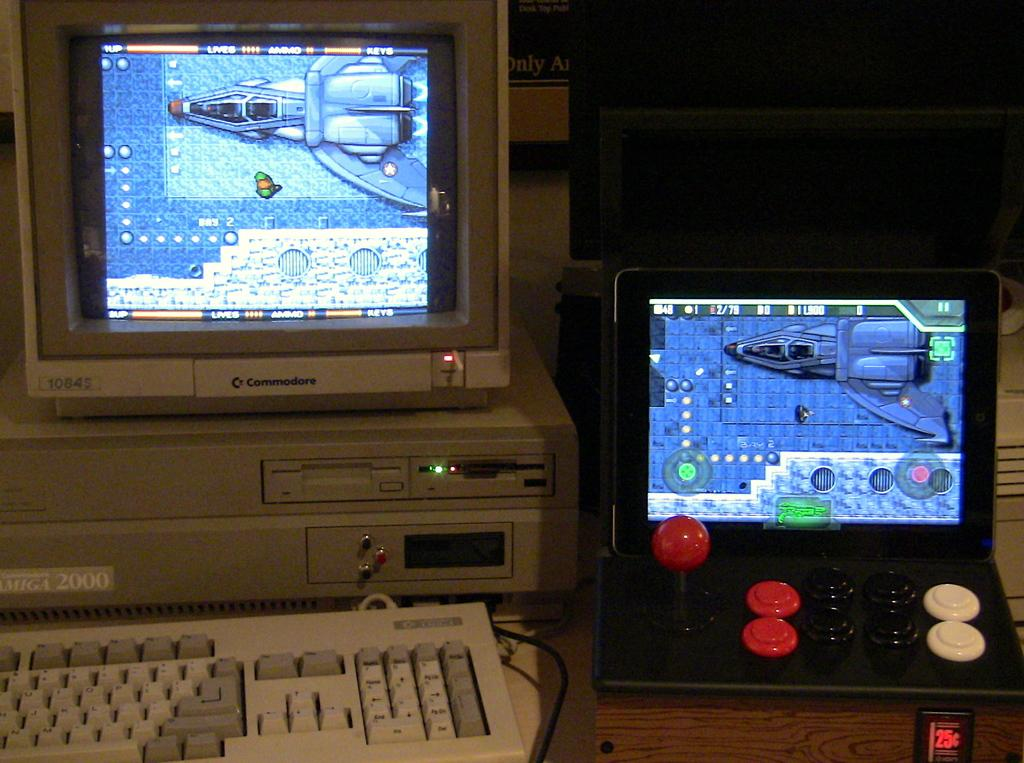Provide a one-sentence caption for the provided image. An old commodore branded computer is sitting next to a small arcade like system. 